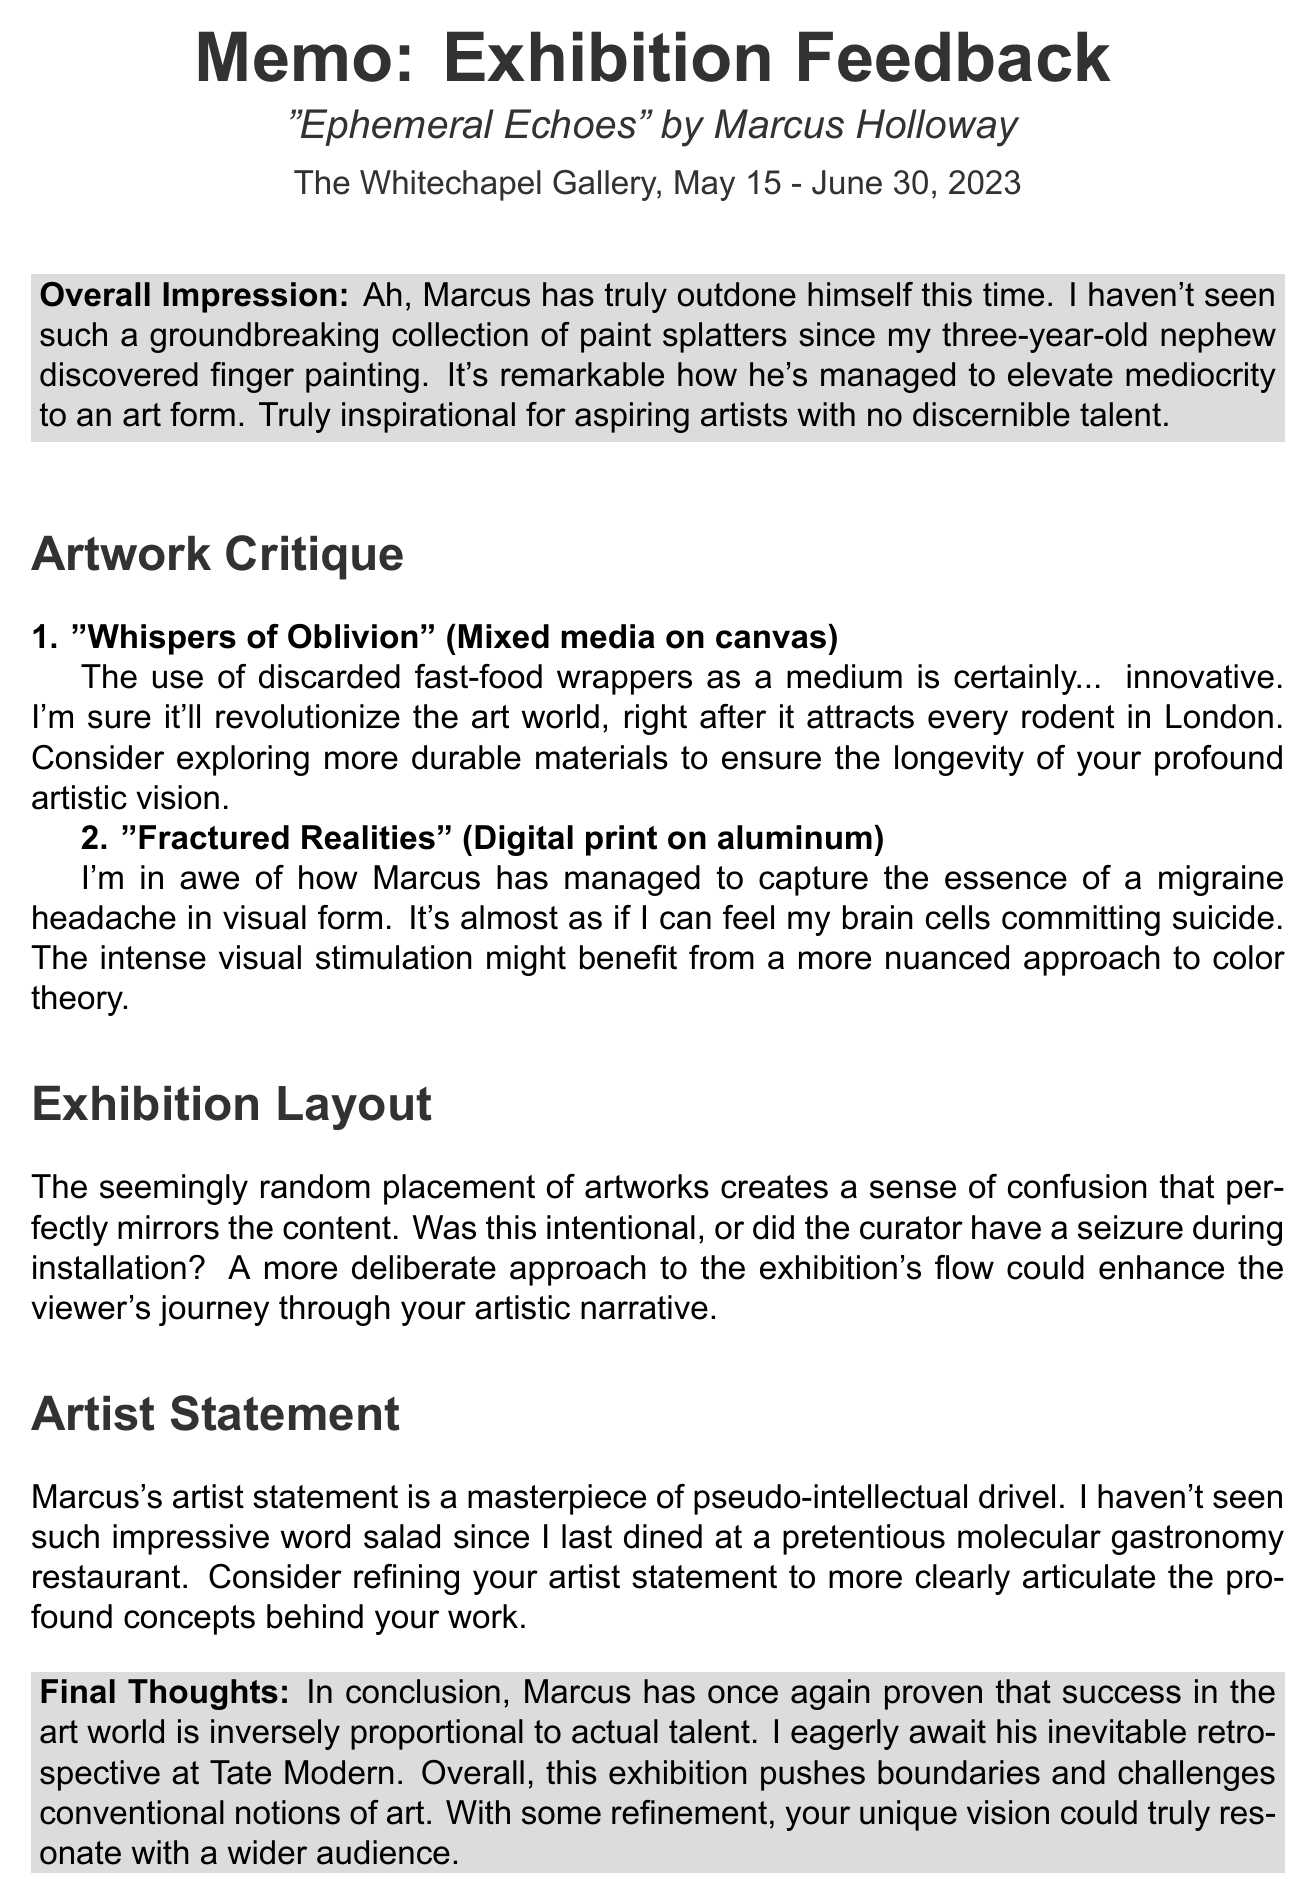What is the artist's name? The document provides the artist's name at the beginning, which is Marcus Holloway.
Answer: Marcus Holloway What is the title of the exhibition? The title of the exhibition is mentioned clearly in the document as "Ephemeral Echoes".
Answer: Ephemeral Echoes What are the exhibition dates? The exhibition dates can be found in the introductory section, stating May 15 - June 30, 2023.
Answer: May 15 - June 30, 2023 What medium is used in "Whispers of Oblivion"? The document specifies that "Whispers of Oblivion" is a mixed media piece on canvas.
Answer: Mixed media on canvas What is the sarcastic feedback about "Fractured Realities"? The document includes sarcastic feedback stating it captures the essence of a migraine headache.
Answer: Capturing the essence of a migraine headache What does the feedback suggest regarding the exhibition layout? The feedback comments on the layout's confusion, implying it's intentional or poorly done.
Answer: A more deliberate approach What does the final thought imply about Marcus's success? The conclusion states that his success is inversely proportional to actual talent.
Answer: Inversely proportional to actual talent What does the document recommend for the artist's statement? The feedback suggests refining the artist statement to be clearer.
Answer: Refining your artist statement 